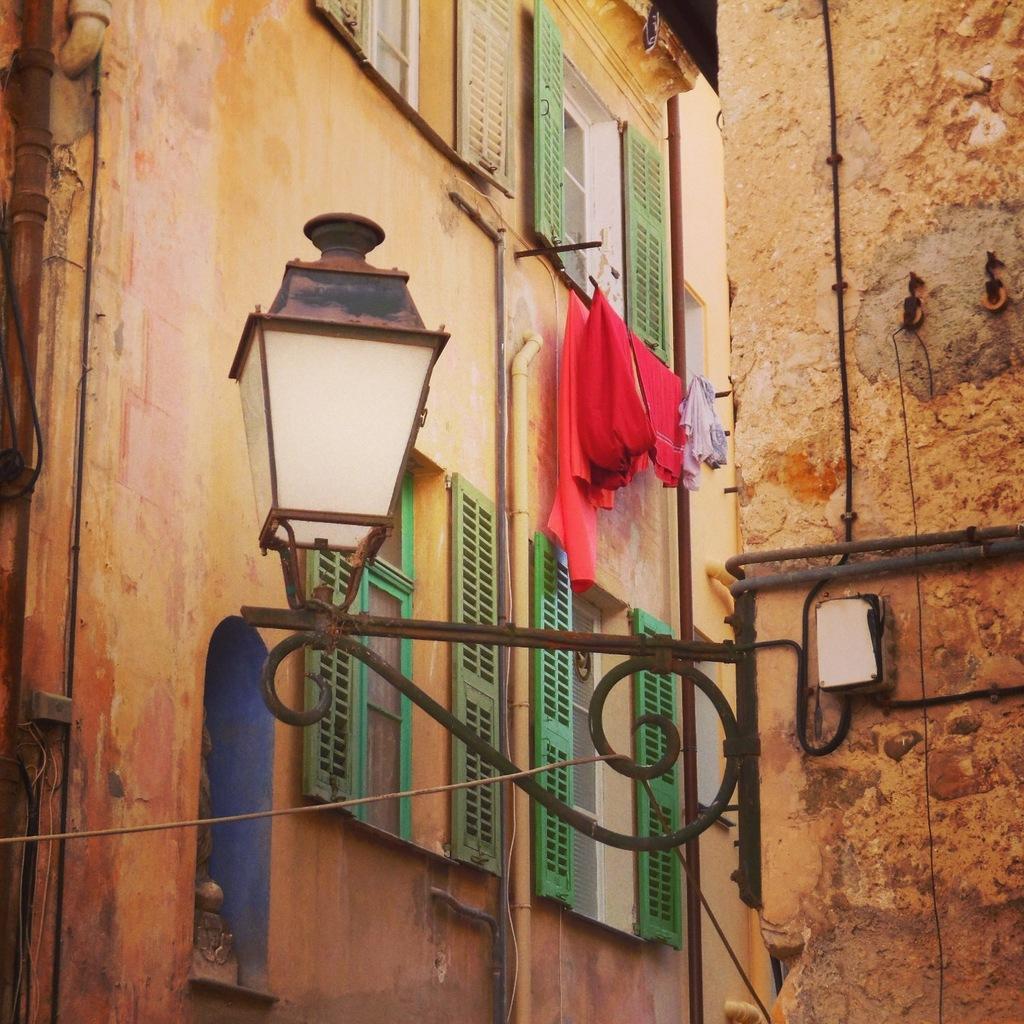Please provide a concise description of this image. In this picture we can see few buildings, metal rods and a light, in the background we can find few clothes and pipes on the wall. 